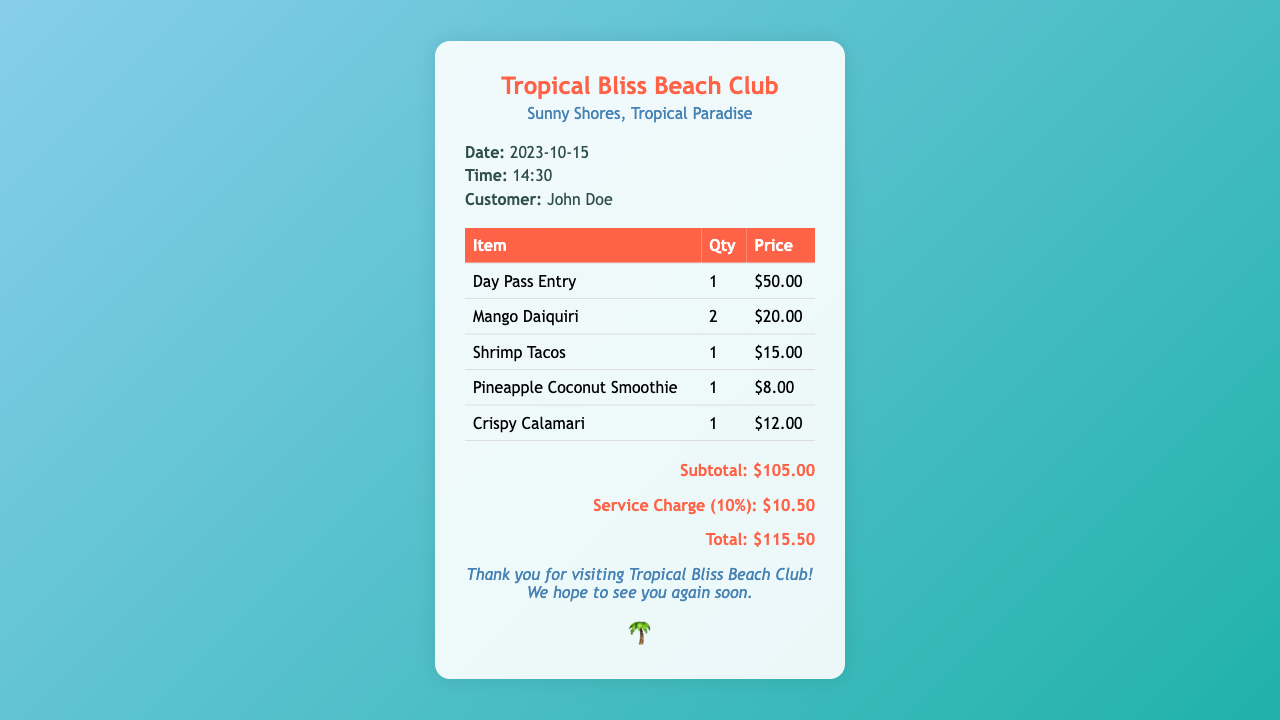What is the date of the receipt? The date of the receipt is provided in the details section.
Answer: 2023-10-15 What is the time listed on the receipt? The time of the transaction is mentioned in the details section.
Answer: 14:30 Who is the customer named on the receipt? The customer's name is found in the details section.
Answer: John Doe What is the price of the Day Pass Entry? The price for the Day Pass Entry is shown in the itemized list.
Answer: $50.00 How many Mango Daiquiris were purchased? The quantity of Mango Daiquiris can be found in the table of items.
Answer: 2 What is the subtotal before the service charge? The subtotal is provided before the service charge in the total section.
Answer: $105.00 What is the service charge percentage? The service charge is specified as a percentage in the total section.
Answer: 10% What is the total amount on the receipt? The total amount is given at the end of the receipt.
Answer: $115.50 What food item has the highest price? The food item with the highest price can be determined from the itemized list.
Answer: Day Pass Entry 